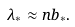<formula> <loc_0><loc_0><loc_500><loc_500>\lambda _ { \ast } \approx n b _ { \ast } .</formula> 